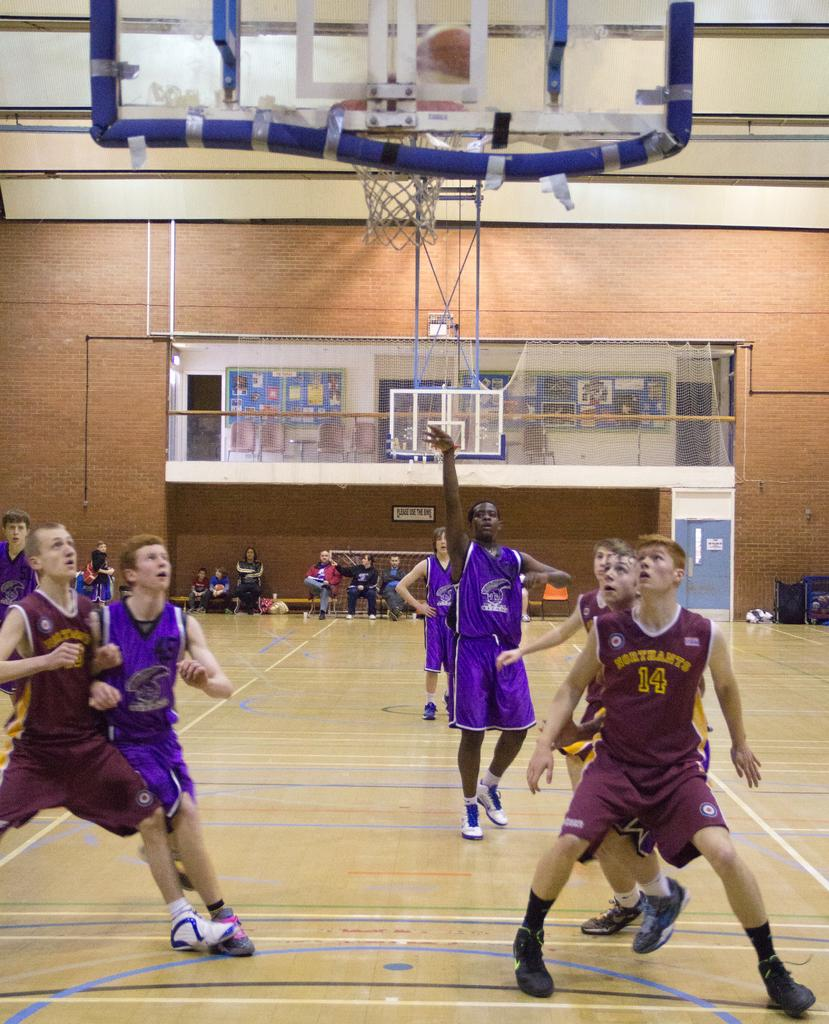<image>
Summarize the visual content of the image. A boy from Northants boxes out while the other player shoots a free throw. 